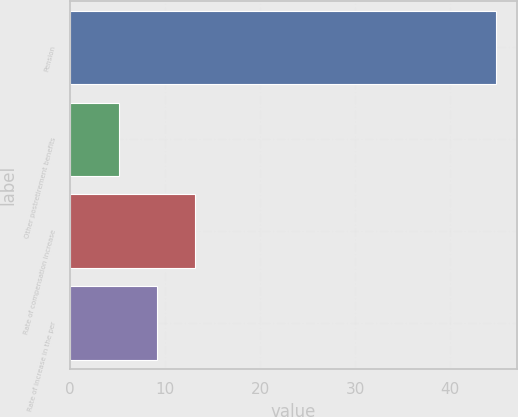Convert chart. <chart><loc_0><loc_0><loc_500><loc_500><bar_chart><fcel>Pension<fcel>Other postretirement benefits<fcel>Rate of compensation increase<fcel>Rate of increase in the per<nl><fcel>44.8<fcel>5.2<fcel>13.12<fcel>9.16<nl></chart> 